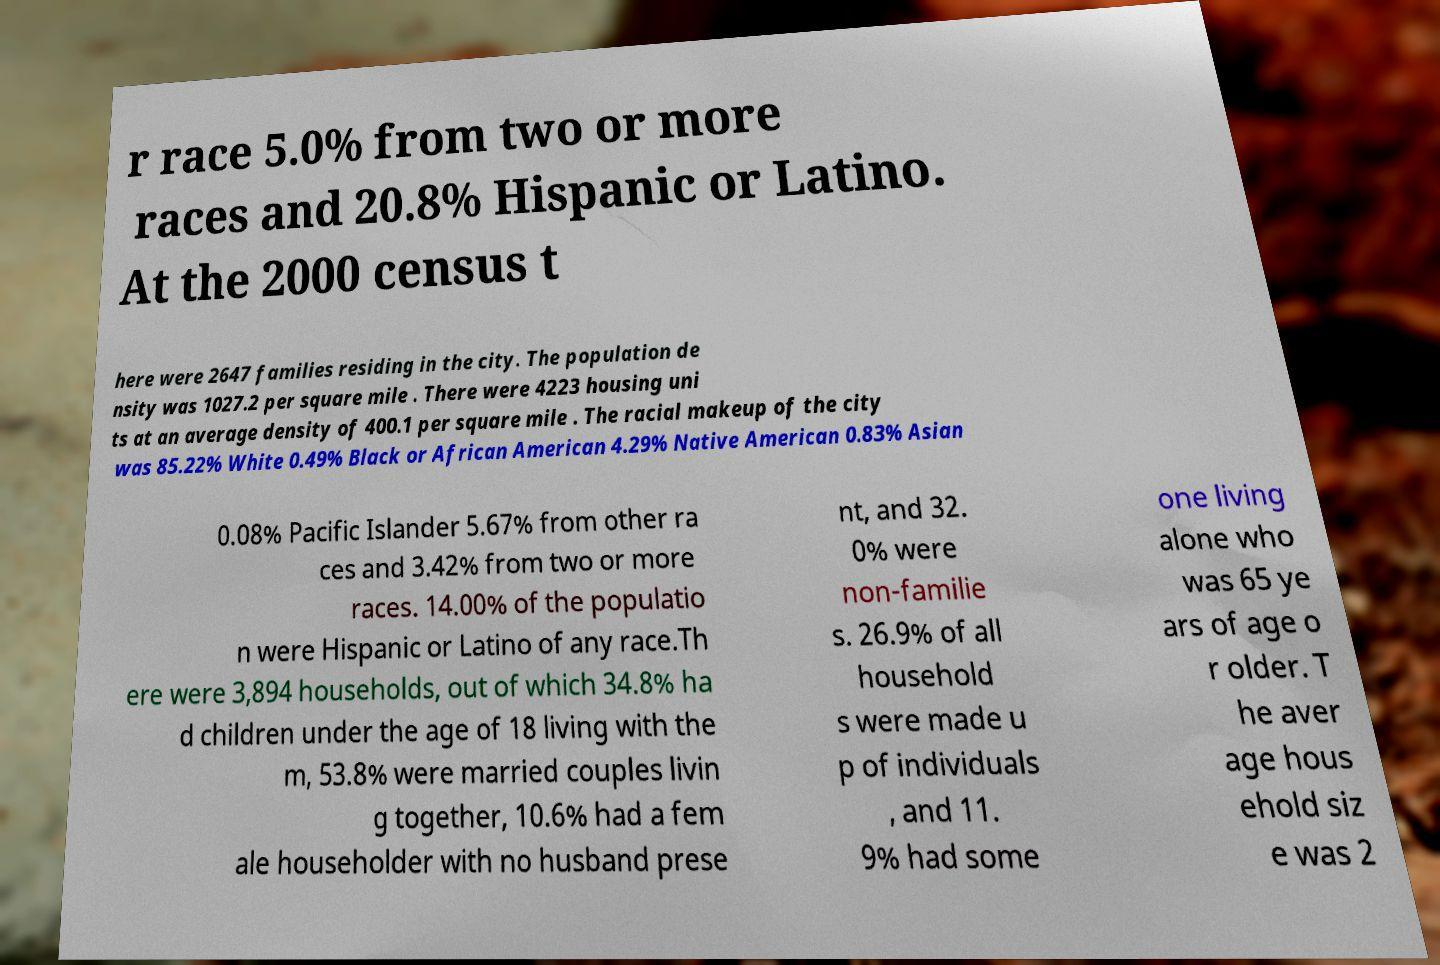Could you extract and type out the text from this image? r race 5.0% from two or more races and 20.8% Hispanic or Latino. At the 2000 census t here were 2647 families residing in the city. The population de nsity was 1027.2 per square mile . There were 4223 housing uni ts at an average density of 400.1 per square mile . The racial makeup of the city was 85.22% White 0.49% Black or African American 4.29% Native American 0.83% Asian 0.08% Pacific Islander 5.67% from other ra ces and 3.42% from two or more races. 14.00% of the populatio n were Hispanic or Latino of any race.Th ere were 3,894 households, out of which 34.8% ha d children under the age of 18 living with the m, 53.8% were married couples livin g together, 10.6% had a fem ale householder with no husband prese nt, and 32. 0% were non-familie s. 26.9% of all household s were made u p of individuals , and 11. 9% had some one living alone who was 65 ye ars of age o r older. T he aver age hous ehold siz e was 2 